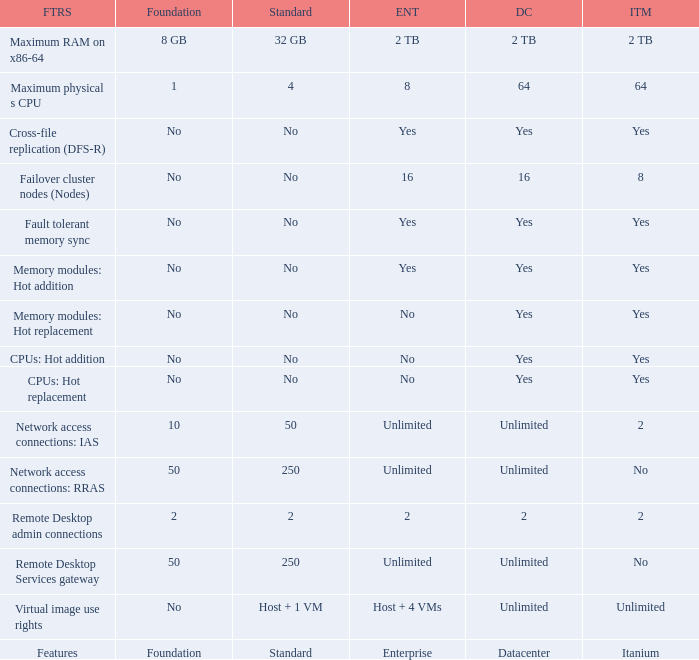What is the Datacenter for the Fault Tolerant Memory Sync Feature that has Yes for Itanium and No for Standard? Yes. 